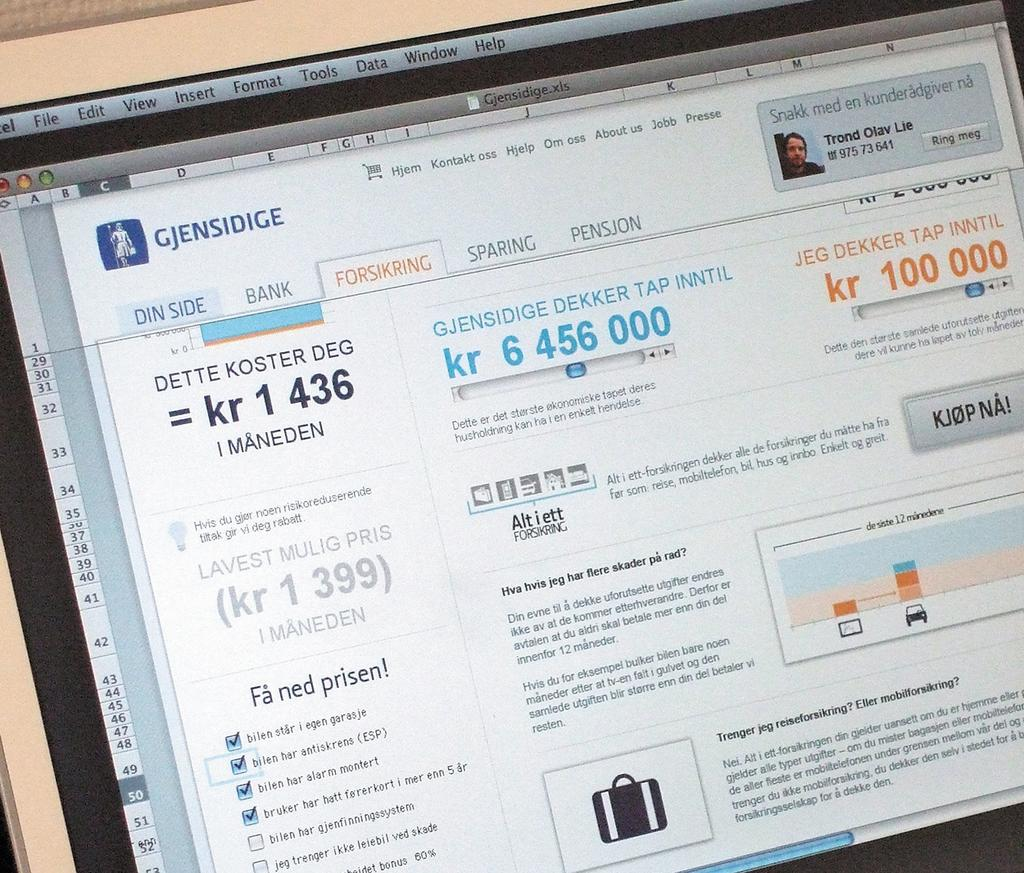<image>
Share a concise interpretation of the image provided. A website with Gjensidige written in the top left 